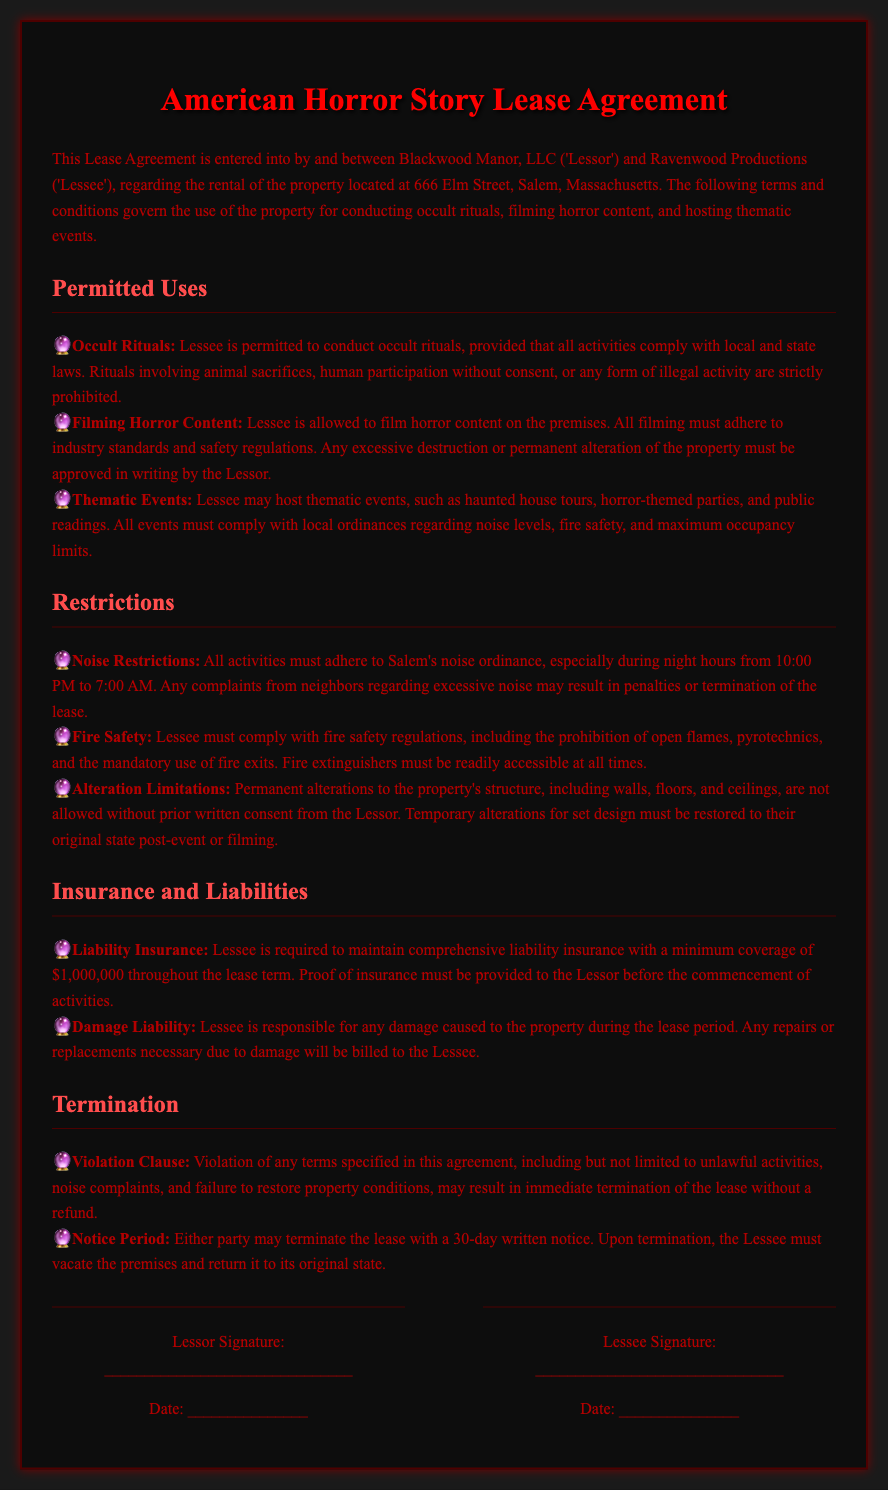what is the location of the property? The property is located at 666 Elm Street, Salem, Massachusetts, as stated at the beginning of the document.
Answer: 666 Elm Street, Salem, Massachusetts what is the minimum liability insurance coverage required? The document specifies that the Lessee must maintain comprehensive liability insurance with a minimum coverage amount.
Answer: $1,000,000 what hours are subject to noise restrictions? The document indicates specific night hours during which noise restrictions apply according to local ordinance.
Answer: 10:00 PM to 7:00 AM what activities are prohibited during occult rituals? The permitted uses section outlines the conditions under which rituals can occur, explicitly mentioning illegal activities that are not allowed.
Answer: animal sacrifices, human participation without consent, illegal activity what must be done to restore temporary alterations? The document mentions that temporary alterations for set design must be handled in a specific way after use.
Answer: must be restored to their original state what is the notice period for lease termination? One of the clauses in the termination section mentions how much notice is needed to terminate the lease.
Answer: 30 days under what condition can the lease be terminated immediately? The violation clause outlines situations leading to immediate lease termination without refund.
Answer: violation of any terms who are the parties involved in the lease agreement? The initial section of the document introduces the parties entering into the lease agreement.
Answer: Blackwood Manor, LLC and Ravenwood Productions 